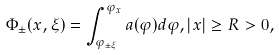<formula> <loc_0><loc_0><loc_500><loc_500>\Phi _ { \pm } ( x , \xi ) = \int _ { \varphi _ { \pm \xi } } ^ { \varphi _ { x } } a ( \varphi ) d \varphi , | x | \geq R > 0 ,</formula> 